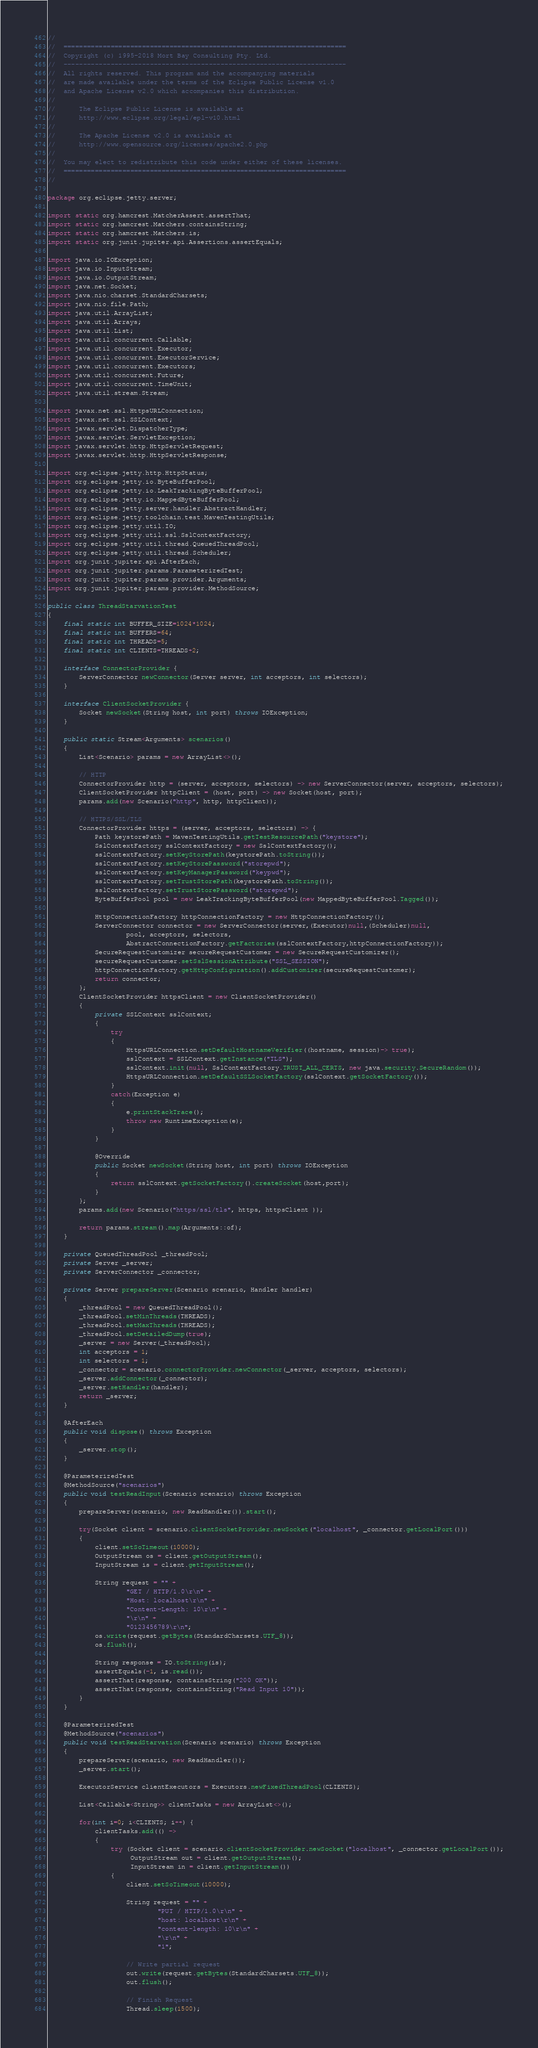<code> <loc_0><loc_0><loc_500><loc_500><_Java_>//
//  ========================================================================
//  Copyright (c) 1995-2018 Mort Bay Consulting Pty. Ltd.
//  ------------------------------------------------------------------------
//  All rights reserved. This program and the accompanying materials
//  are made available under the terms of the Eclipse Public License v1.0
//  and Apache License v2.0 which accompanies this distribution.
//
//      The Eclipse Public License is available at
//      http://www.eclipse.org/legal/epl-v10.html
//
//      The Apache License v2.0 is available at
//      http://www.opensource.org/licenses/apache2.0.php
//
//  You may elect to redistribute this code under either of these licenses.
//  ========================================================================
//

package org.eclipse.jetty.server;

import static org.hamcrest.MatcherAssert.assertThat;
import static org.hamcrest.Matchers.containsString;
import static org.hamcrest.Matchers.is;
import static org.junit.jupiter.api.Assertions.assertEquals;

import java.io.IOException;
import java.io.InputStream;
import java.io.OutputStream;
import java.net.Socket;
import java.nio.charset.StandardCharsets;
import java.nio.file.Path;
import java.util.ArrayList;
import java.util.Arrays;
import java.util.List;
import java.util.concurrent.Callable;
import java.util.concurrent.Executor;
import java.util.concurrent.ExecutorService;
import java.util.concurrent.Executors;
import java.util.concurrent.Future;
import java.util.concurrent.TimeUnit;
import java.util.stream.Stream;

import javax.net.ssl.HttpsURLConnection;
import javax.net.ssl.SSLContext;
import javax.servlet.DispatcherType;
import javax.servlet.ServletException;
import javax.servlet.http.HttpServletRequest;
import javax.servlet.http.HttpServletResponse;

import org.eclipse.jetty.http.HttpStatus;
import org.eclipse.jetty.io.ByteBufferPool;
import org.eclipse.jetty.io.LeakTrackingByteBufferPool;
import org.eclipse.jetty.io.MappedByteBufferPool;
import org.eclipse.jetty.server.handler.AbstractHandler;
import org.eclipse.jetty.toolchain.test.MavenTestingUtils;
import org.eclipse.jetty.util.IO;
import org.eclipse.jetty.util.ssl.SslContextFactory;
import org.eclipse.jetty.util.thread.QueuedThreadPool;
import org.eclipse.jetty.util.thread.Scheduler;
import org.junit.jupiter.api.AfterEach;
import org.junit.jupiter.params.ParameterizedTest;
import org.junit.jupiter.params.provider.Arguments;
import org.junit.jupiter.params.provider.MethodSource;

public class ThreadStarvationTest
{
    final static int BUFFER_SIZE=1024*1024;
    final static int BUFFERS=64;
    final static int THREADS=5;
    final static int CLIENTS=THREADS+2;

    interface ConnectorProvider {
        ServerConnector newConnector(Server server, int acceptors, int selectors);
    }
    
    interface ClientSocketProvider {
        Socket newSocket(String host, int port) throws IOException;
    }
    
    public static Stream<Arguments> scenarios()
    {
        List<Scenario> params = new ArrayList<>();
        
        // HTTP
        ConnectorProvider http = (server, acceptors, selectors) -> new ServerConnector(server, acceptors, selectors);
        ClientSocketProvider httpClient = (host, port) -> new Socket(host, port);
        params.add(new Scenario("http", http, httpClient));
        
        // HTTPS/SSL/TLS
        ConnectorProvider https = (server, acceptors, selectors) -> {
            Path keystorePath = MavenTestingUtils.getTestResourcePath("keystore");
            SslContextFactory sslContextFactory = new SslContextFactory();
            sslContextFactory.setKeyStorePath(keystorePath.toString());
            sslContextFactory.setKeyStorePassword("storepwd");
            sslContextFactory.setKeyManagerPassword("keypwd");
            sslContextFactory.setTrustStorePath(keystorePath.toString());
            sslContextFactory.setTrustStorePassword("storepwd");
            ByteBufferPool pool = new LeakTrackingByteBufferPool(new MappedByteBufferPool.Tagged());
    
            HttpConnectionFactory httpConnectionFactory = new HttpConnectionFactory();
            ServerConnector connector = new ServerConnector(server,(Executor)null,(Scheduler)null,
                    pool, acceptors, selectors,
                    AbstractConnectionFactory.getFactories(sslContextFactory,httpConnectionFactory));
            SecureRequestCustomizer secureRequestCustomer = new SecureRequestCustomizer();
            secureRequestCustomer.setSslSessionAttribute("SSL_SESSION");
            httpConnectionFactory.getHttpConfiguration().addCustomizer(secureRequestCustomer);
            return connector;
        };
        ClientSocketProvider httpsClient = new ClientSocketProvider()
        {
            private SSLContext sslContext;
            {
                try
                {
                    HttpsURLConnection.setDefaultHostnameVerifier((hostname, session)-> true);
                    sslContext = SSLContext.getInstance("TLS");
                    sslContext.init(null, SslContextFactory.TRUST_ALL_CERTS, new java.security.SecureRandom());
                    HttpsURLConnection.setDefaultSSLSocketFactory(sslContext.getSocketFactory());
                }
                catch(Exception e)
                {
                    e.printStackTrace();
                    throw new RuntimeException(e);
                }
            }
            
            @Override
            public Socket newSocket(String host, int port) throws IOException
            {
                return sslContext.getSocketFactory().createSocket(host,port);
            }
        };
        params.add(new Scenario("https/ssl/tls", https, httpsClient ));
        
        return params.stream().map(Arguments::of);
    }
    
    private QueuedThreadPool _threadPool;
    private Server _server;
    private ServerConnector _connector;

    private Server prepareServer(Scenario scenario, Handler handler)
    {
        _threadPool = new QueuedThreadPool();
        _threadPool.setMinThreads(THREADS);
        _threadPool.setMaxThreads(THREADS);
        _threadPool.setDetailedDump(true);
        _server = new Server(_threadPool);
        int acceptors = 1;
        int selectors = 1;
        _connector = scenario.connectorProvider.newConnector(_server, acceptors, selectors);
        _server.addConnector(_connector);
        _server.setHandler(handler);
        return _server;
    }

    @AfterEach
    public void dispose() throws Exception
    {
        _server.stop();
    }

    @ParameterizedTest
    @MethodSource("scenarios")
    public void testReadInput(Scenario scenario) throws Exception
    {
        prepareServer(scenario, new ReadHandler()).start();

        try(Socket client = scenario.clientSocketProvider.newSocket("localhost", _connector.getLocalPort()))
        {
            client.setSoTimeout(10000);
            OutputStream os = client.getOutputStream();
            InputStream is = client.getInputStream();
    
            String request = "" +
                    "GET / HTTP/1.0\r\n" +
                    "Host: localhost\r\n" +
                    "Content-Length: 10\r\n" +
                    "\r\n" +
                    "0123456789\r\n";
            os.write(request.getBytes(StandardCharsets.UTF_8));
            os.flush();
    
            String response = IO.toString(is);
            assertEquals(-1, is.read());
            assertThat(response, containsString("200 OK"));
            assertThat(response, containsString("Read Input 10"));
        }
    }

    @ParameterizedTest
    @MethodSource("scenarios")
    public void testReadStarvation(Scenario scenario) throws Exception
    {
        prepareServer(scenario, new ReadHandler());
        _server.start();
    
        ExecutorService clientExecutors = Executors.newFixedThreadPool(CLIENTS);
        
        List<Callable<String>> clientTasks = new ArrayList<>();
        
        for(int i=0; i<CLIENTS; i++) {
            clientTasks.add(() ->
            {
                try (Socket client = scenario.clientSocketProvider.newSocket("localhost", _connector.getLocalPort());
                     OutputStream out = client.getOutputStream();
                     InputStream in = client.getInputStream())
                {
                    client.setSoTimeout(10000);

                    String request = "" +
                            "PUT / HTTP/1.0\r\n" +
                            "host: localhost\r\n" +
                            "content-length: 10\r\n" +
                            "\r\n" +
                            "1";
                    
                    // Write partial request
                    out.write(request.getBytes(StandardCharsets.UTF_8));
                    out.flush();
    
                    // Finish Request
                    Thread.sleep(1500);</code> 